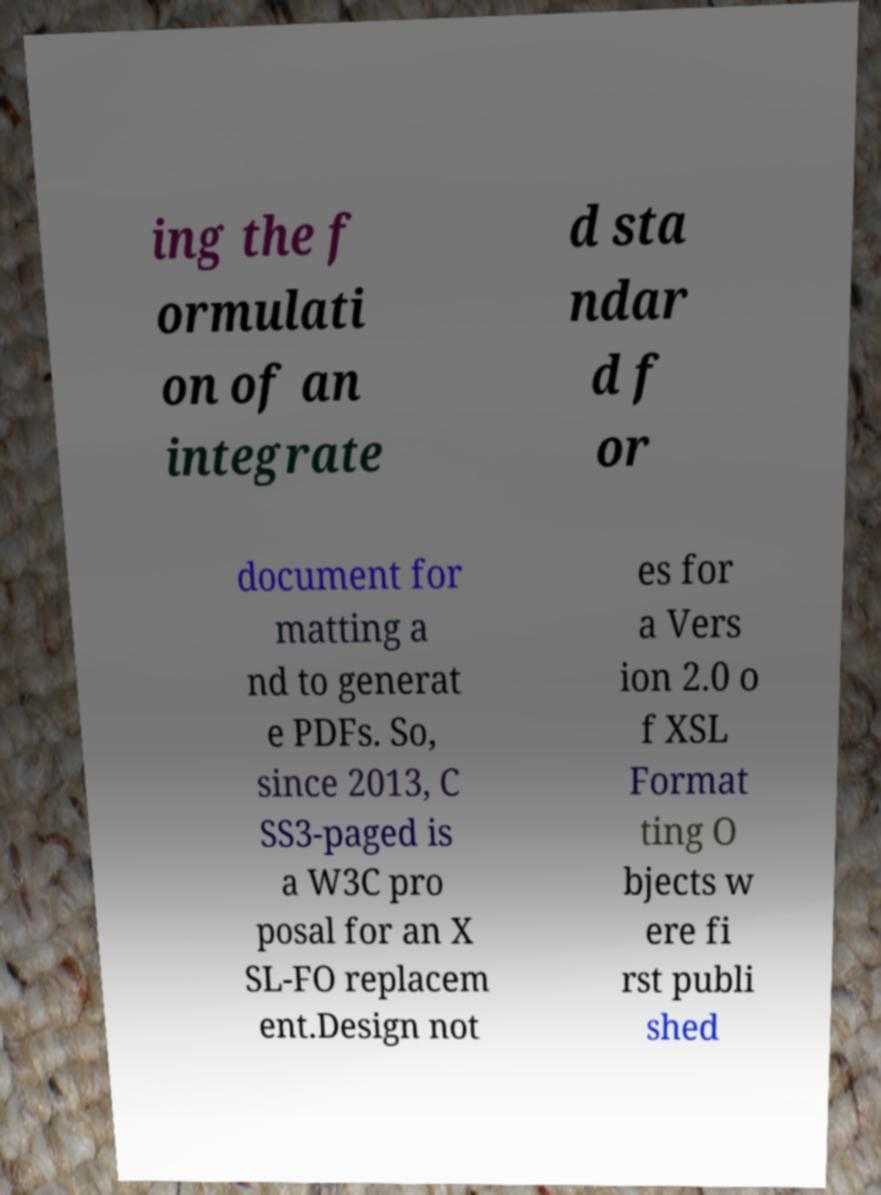What messages or text are displayed in this image? I need them in a readable, typed format. ing the f ormulati on of an integrate d sta ndar d f or document for matting a nd to generat e PDFs. So, since 2013, C SS3-paged is a W3C pro posal for an X SL-FO replacem ent.Design not es for a Vers ion 2.0 o f XSL Format ting O bjects w ere fi rst publi shed 